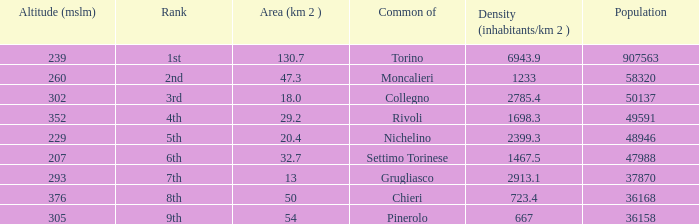What is the density of the common with an area of 20.4 km^2? 2399.3. 